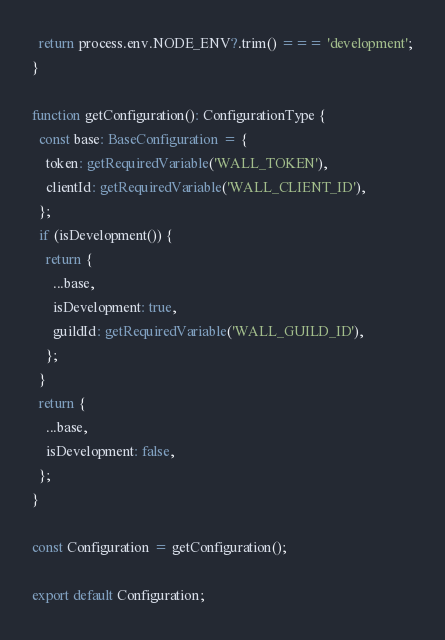Convert code to text. <code><loc_0><loc_0><loc_500><loc_500><_TypeScript_>  return process.env.NODE_ENV?.trim() === 'development';
}

function getConfiguration(): ConfigurationType {
  const base: BaseConfiguration = {
    token: getRequiredVariable('WALL_TOKEN'),
    clientId: getRequiredVariable('WALL_CLIENT_ID'),
  };
  if (isDevelopment()) {
    return {
      ...base,
      isDevelopment: true,
      guildId: getRequiredVariable('WALL_GUILD_ID'),
    };
  }
  return {
    ...base,
    isDevelopment: false,
  };
}

const Configuration = getConfiguration();

export default Configuration;
</code> 